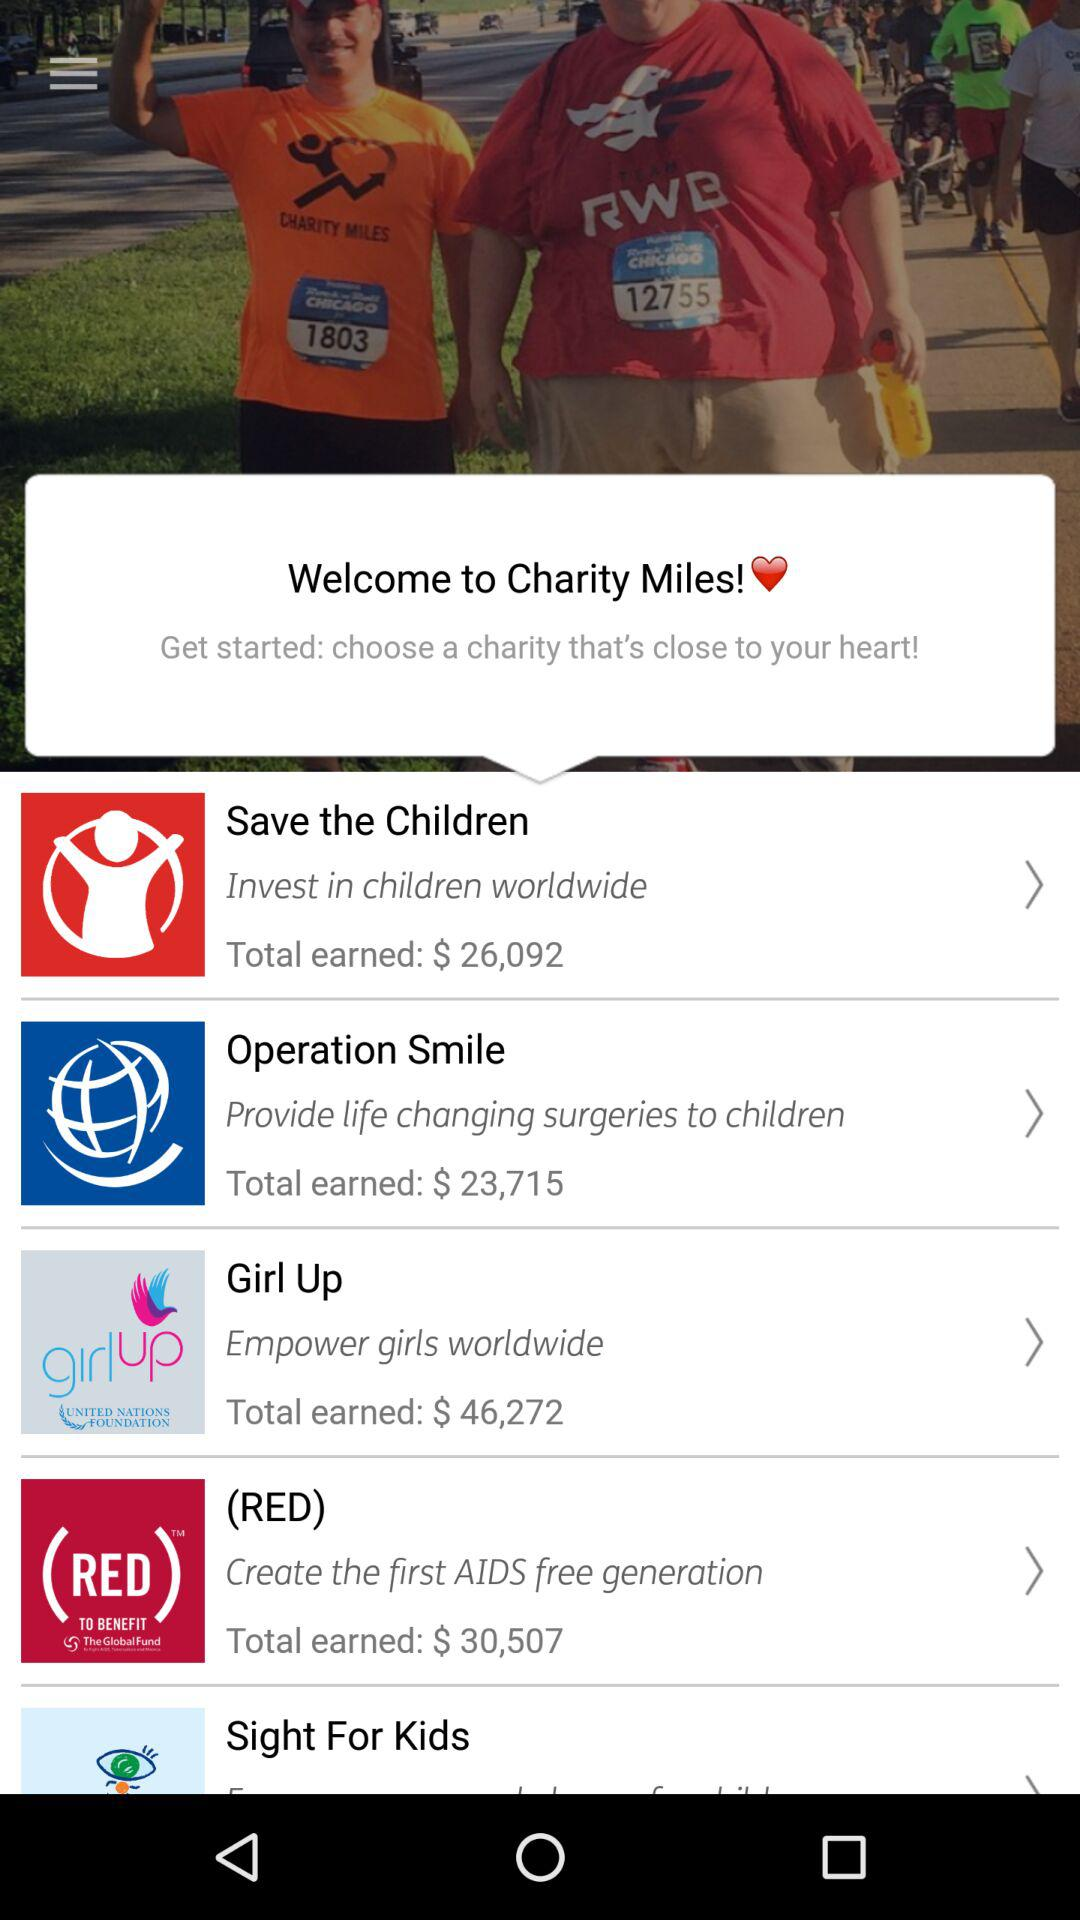How many charities have earned more than $25,000?
Answer the question using a single word or phrase. 3 